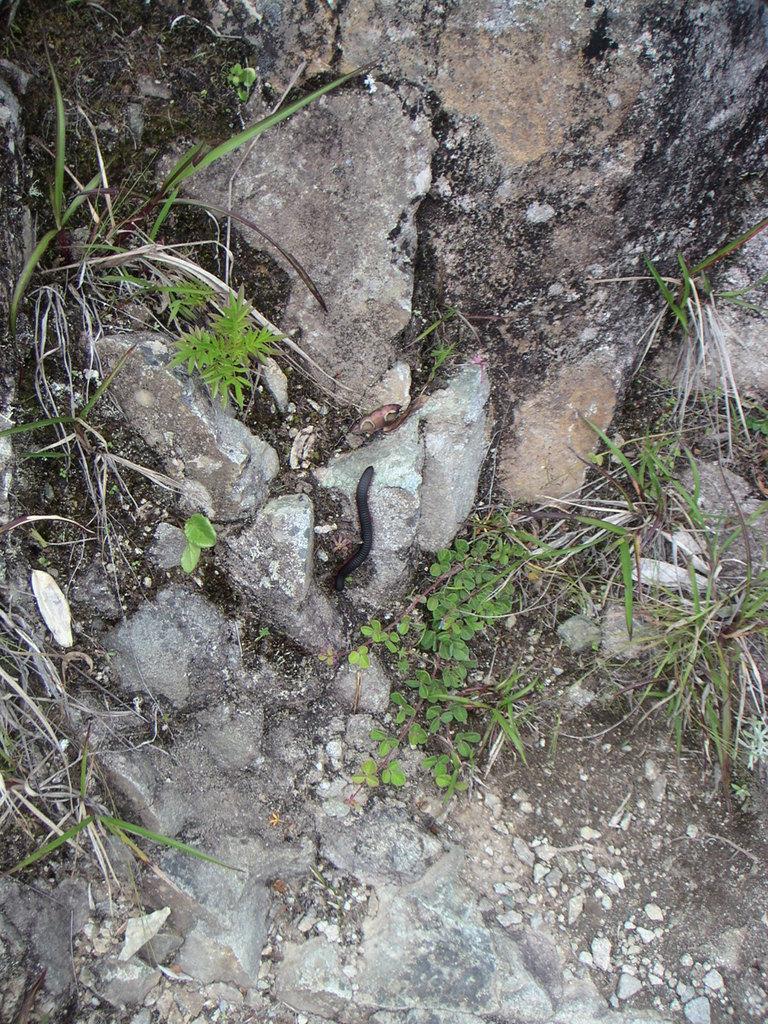Can you describe this image briefly? In this image, I can see an insect. There are rocks and grass. 